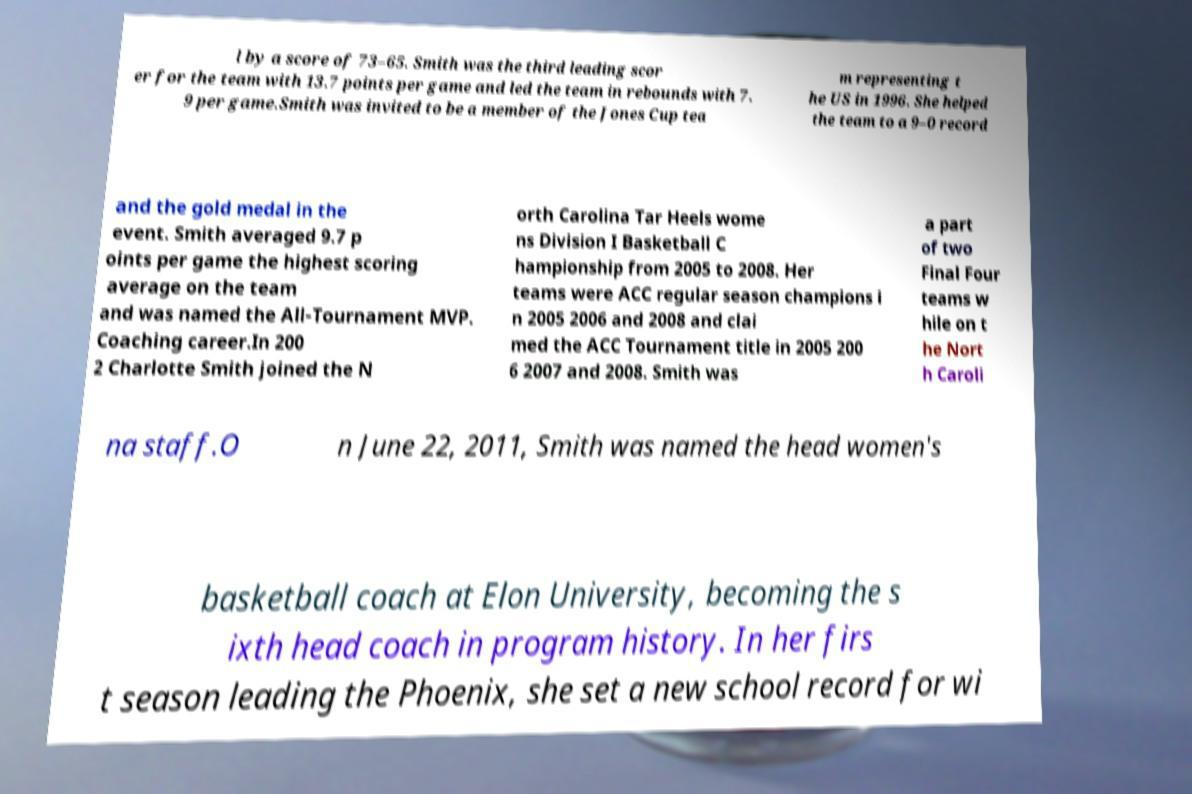There's text embedded in this image that I need extracted. Can you transcribe it verbatim? l by a score of 73–65. Smith was the third leading scor er for the team with 13.7 points per game and led the team in rebounds with 7. 9 per game.Smith was invited to be a member of the Jones Cup tea m representing t he US in 1996. She helped the team to a 9–0 record and the gold medal in the event. Smith averaged 9.7 p oints per game the highest scoring average on the team and was named the All-Tournament MVP. Coaching career.In 200 2 Charlotte Smith joined the N orth Carolina Tar Heels wome ns Division I Basketball C hampionship from 2005 to 2008. Her teams were ACC regular season champions i n 2005 2006 and 2008 and clai med the ACC Tournament title in 2005 200 6 2007 and 2008. Smith was a part of two Final Four teams w hile on t he Nort h Caroli na staff.O n June 22, 2011, Smith was named the head women's basketball coach at Elon University, becoming the s ixth head coach in program history. In her firs t season leading the Phoenix, she set a new school record for wi 